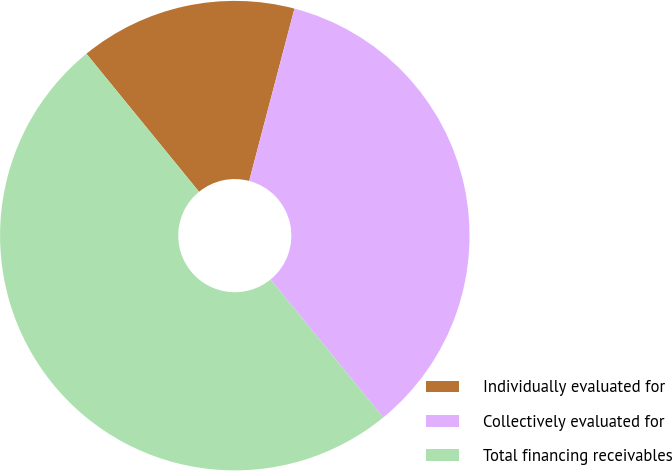Convert chart to OTSL. <chart><loc_0><loc_0><loc_500><loc_500><pie_chart><fcel>Individually evaluated for<fcel>Collectively evaluated for<fcel>Total financing receivables<nl><fcel>14.98%<fcel>35.02%<fcel>50.0%<nl></chart> 